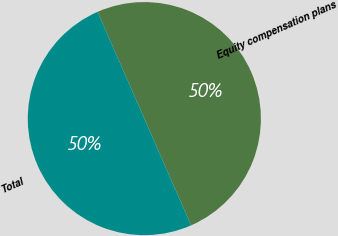<chart> <loc_0><loc_0><loc_500><loc_500><pie_chart><fcel>Equity compensation plans<fcel>Total<nl><fcel>50.0%<fcel>50.0%<nl></chart> 